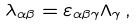Convert formula to latex. <formula><loc_0><loc_0><loc_500><loc_500>\lambda _ { \alpha \beta } = \varepsilon _ { \alpha \beta \gamma } \Lambda _ { \gamma } \, ,</formula> 